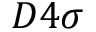Convert formula to latex. <formula><loc_0><loc_0><loc_500><loc_500>D 4 \sigma</formula> 